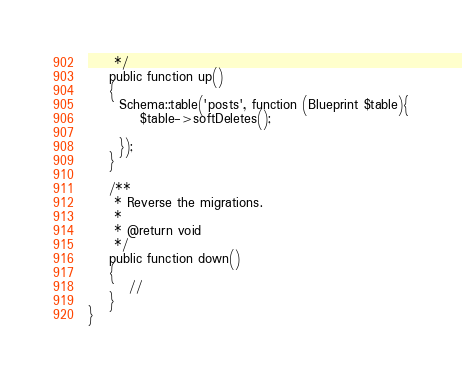Convert code to text. <code><loc_0><loc_0><loc_500><loc_500><_PHP_>     */
    public function up()
    {
      Schema::table('posts', function (Blueprint $table){
          $table->softDeletes();
          
      });
    }

    /**
     * Reverse the migrations.
     *
     * @return void
     */
    public function down()
    {
        //
    }
}
</code> 